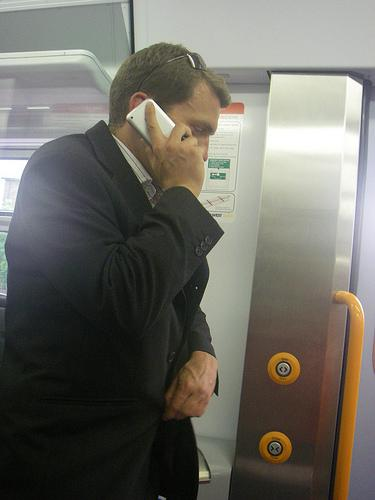Question: what is the man doing?
Choices:
A. Typing on a laptop.
B. Looking at an ipad.
C. Looking at a camera.
D. Talking on a phone.
Answer with the letter. Answer: D Question: what color is the phone?
Choices:
A. White.
B. Pink.
C. Gold.
D. Silver.
Answer with the letter. Answer: A Question: what is the man holding to his ear?
Choices:
A. An earbud.
B. A phone.
C. Headphones.
D. A hearing aid.
Answer with the letter. Answer: B Question: what does the man have on his head?
Choices:
A. Hat.
B. Cap.
C. Kerchief.
D. Sunglasses.
Answer with the letter. Answer: D 